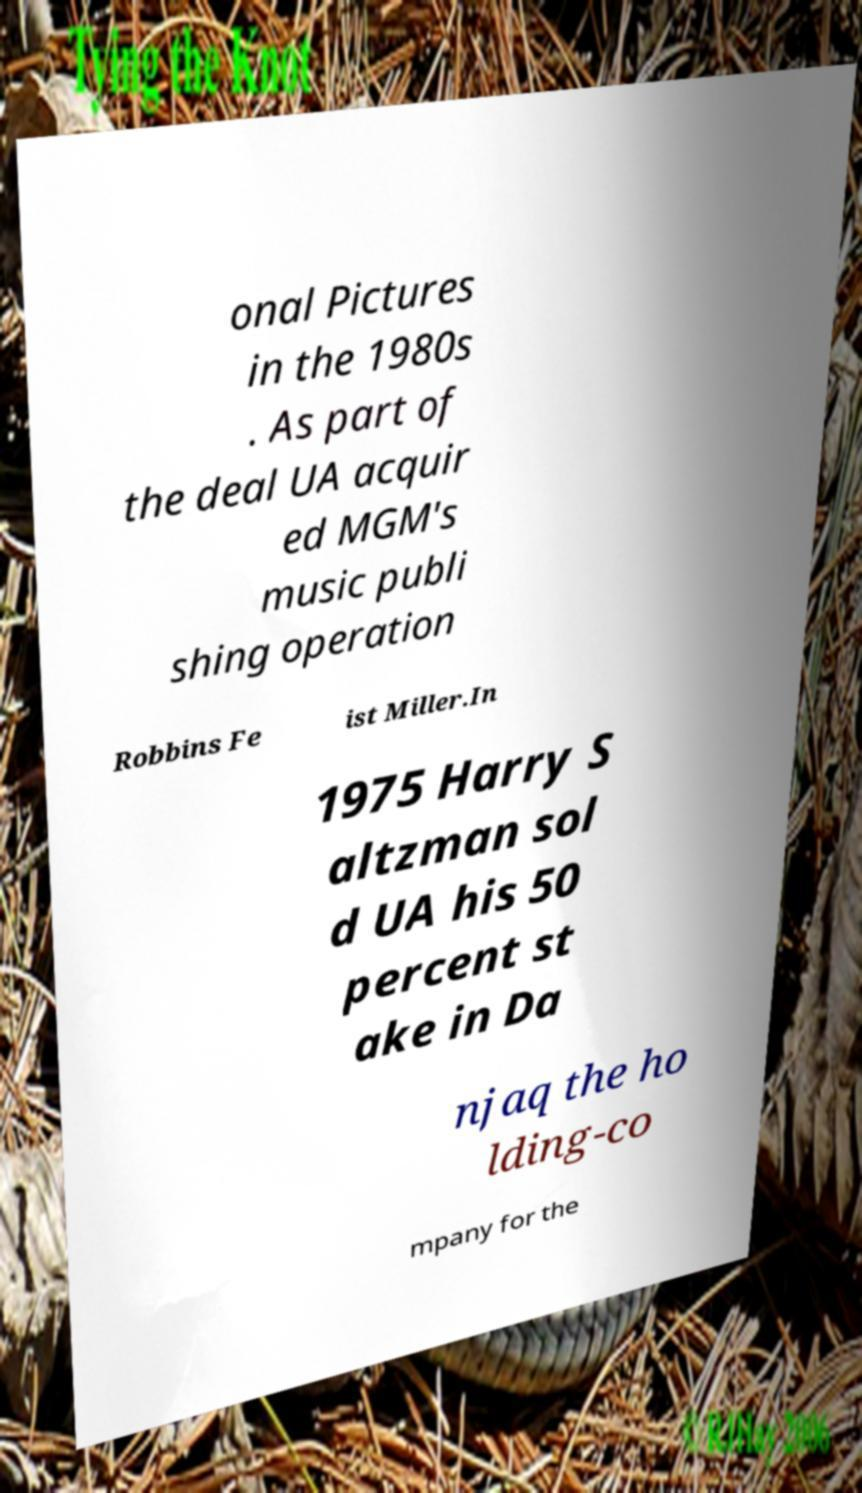Can you accurately transcribe the text from the provided image for me? onal Pictures in the 1980s . As part of the deal UA acquir ed MGM's music publi shing operation Robbins Fe ist Miller.In 1975 Harry S altzman sol d UA his 50 percent st ake in Da njaq the ho lding-co mpany for the 